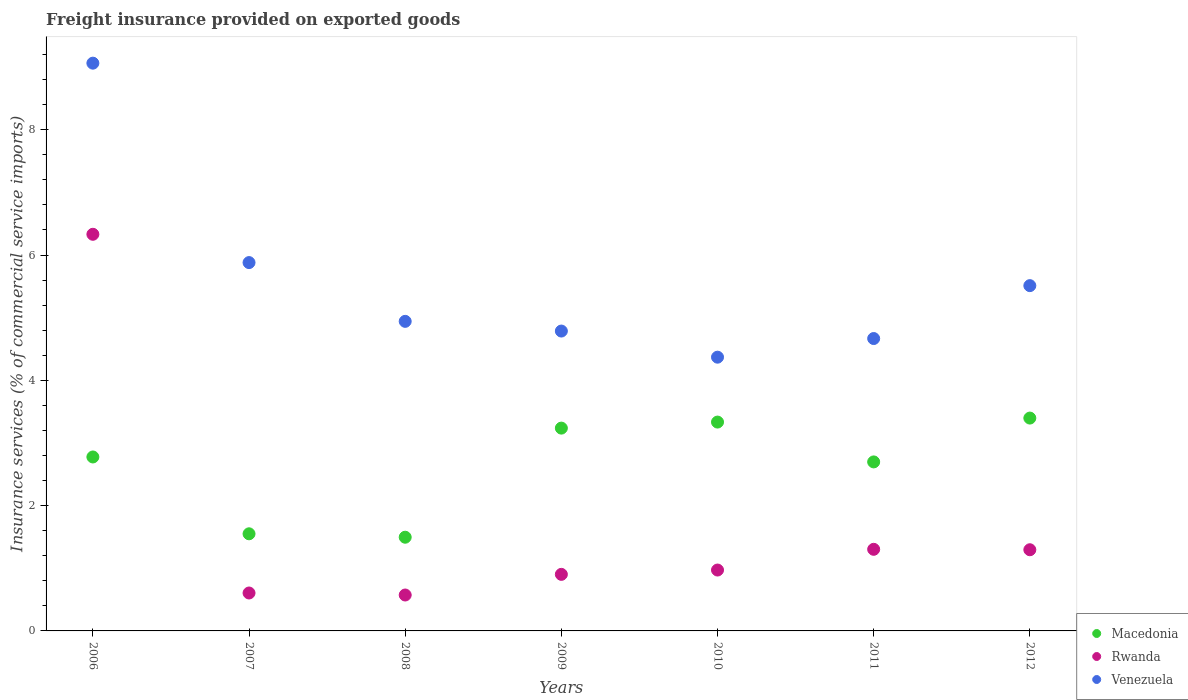How many different coloured dotlines are there?
Your answer should be very brief. 3. What is the freight insurance provided on exported goods in Macedonia in 2008?
Your answer should be very brief. 1.5. Across all years, what is the maximum freight insurance provided on exported goods in Venezuela?
Your response must be concise. 9.06. Across all years, what is the minimum freight insurance provided on exported goods in Macedonia?
Keep it short and to the point. 1.5. What is the total freight insurance provided on exported goods in Rwanda in the graph?
Offer a terse response. 11.98. What is the difference between the freight insurance provided on exported goods in Rwanda in 2008 and that in 2012?
Ensure brevity in your answer.  -0.72. What is the difference between the freight insurance provided on exported goods in Macedonia in 2006 and the freight insurance provided on exported goods in Rwanda in 2012?
Make the answer very short. 1.48. What is the average freight insurance provided on exported goods in Rwanda per year?
Keep it short and to the point. 1.71. In the year 2008, what is the difference between the freight insurance provided on exported goods in Rwanda and freight insurance provided on exported goods in Venezuela?
Your response must be concise. -4.37. In how many years, is the freight insurance provided on exported goods in Rwanda greater than 4 %?
Offer a very short reply. 1. What is the ratio of the freight insurance provided on exported goods in Rwanda in 2007 to that in 2012?
Provide a succinct answer. 0.47. Is the difference between the freight insurance provided on exported goods in Rwanda in 2011 and 2012 greater than the difference between the freight insurance provided on exported goods in Venezuela in 2011 and 2012?
Offer a terse response. Yes. What is the difference between the highest and the second highest freight insurance provided on exported goods in Rwanda?
Ensure brevity in your answer.  5.03. What is the difference between the highest and the lowest freight insurance provided on exported goods in Macedonia?
Give a very brief answer. 1.9. In how many years, is the freight insurance provided on exported goods in Venezuela greater than the average freight insurance provided on exported goods in Venezuela taken over all years?
Your answer should be compact. 2. Is the freight insurance provided on exported goods in Venezuela strictly less than the freight insurance provided on exported goods in Macedonia over the years?
Offer a terse response. No. What is the difference between two consecutive major ticks on the Y-axis?
Give a very brief answer. 2. Are the values on the major ticks of Y-axis written in scientific E-notation?
Provide a short and direct response. No. Does the graph contain any zero values?
Offer a terse response. No. Does the graph contain grids?
Ensure brevity in your answer.  No. How many legend labels are there?
Your response must be concise. 3. How are the legend labels stacked?
Give a very brief answer. Vertical. What is the title of the graph?
Provide a succinct answer. Freight insurance provided on exported goods. Does "Mongolia" appear as one of the legend labels in the graph?
Provide a succinct answer. No. What is the label or title of the Y-axis?
Offer a very short reply. Insurance services (% of commercial service imports). What is the Insurance services (% of commercial service imports) of Macedonia in 2006?
Your response must be concise. 2.78. What is the Insurance services (% of commercial service imports) of Rwanda in 2006?
Ensure brevity in your answer.  6.33. What is the Insurance services (% of commercial service imports) in Venezuela in 2006?
Keep it short and to the point. 9.06. What is the Insurance services (% of commercial service imports) in Macedonia in 2007?
Provide a short and direct response. 1.55. What is the Insurance services (% of commercial service imports) in Rwanda in 2007?
Keep it short and to the point. 0.61. What is the Insurance services (% of commercial service imports) of Venezuela in 2007?
Ensure brevity in your answer.  5.88. What is the Insurance services (% of commercial service imports) in Macedonia in 2008?
Make the answer very short. 1.5. What is the Insurance services (% of commercial service imports) in Rwanda in 2008?
Your response must be concise. 0.57. What is the Insurance services (% of commercial service imports) in Venezuela in 2008?
Provide a short and direct response. 4.94. What is the Insurance services (% of commercial service imports) of Macedonia in 2009?
Give a very brief answer. 3.24. What is the Insurance services (% of commercial service imports) in Rwanda in 2009?
Your response must be concise. 0.9. What is the Insurance services (% of commercial service imports) of Venezuela in 2009?
Provide a short and direct response. 4.79. What is the Insurance services (% of commercial service imports) in Macedonia in 2010?
Provide a short and direct response. 3.33. What is the Insurance services (% of commercial service imports) of Rwanda in 2010?
Offer a very short reply. 0.97. What is the Insurance services (% of commercial service imports) in Venezuela in 2010?
Your answer should be very brief. 4.37. What is the Insurance services (% of commercial service imports) of Macedonia in 2011?
Give a very brief answer. 2.7. What is the Insurance services (% of commercial service imports) of Rwanda in 2011?
Your answer should be compact. 1.3. What is the Insurance services (% of commercial service imports) in Venezuela in 2011?
Provide a succinct answer. 4.67. What is the Insurance services (% of commercial service imports) in Macedonia in 2012?
Offer a terse response. 3.4. What is the Insurance services (% of commercial service imports) in Rwanda in 2012?
Your answer should be very brief. 1.3. What is the Insurance services (% of commercial service imports) in Venezuela in 2012?
Keep it short and to the point. 5.51. Across all years, what is the maximum Insurance services (% of commercial service imports) in Macedonia?
Make the answer very short. 3.4. Across all years, what is the maximum Insurance services (% of commercial service imports) of Rwanda?
Provide a succinct answer. 6.33. Across all years, what is the maximum Insurance services (% of commercial service imports) in Venezuela?
Your response must be concise. 9.06. Across all years, what is the minimum Insurance services (% of commercial service imports) in Macedonia?
Offer a terse response. 1.5. Across all years, what is the minimum Insurance services (% of commercial service imports) of Rwanda?
Offer a very short reply. 0.57. Across all years, what is the minimum Insurance services (% of commercial service imports) of Venezuela?
Your answer should be compact. 4.37. What is the total Insurance services (% of commercial service imports) in Macedonia in the graph?
Your answer should be compact. 18.49. What is the total Insurance services (% of commercial service imports) of Rwanda in the graph?
Offer a very short reply. 11.98. What is the total Insurance services (% of commercial service imports) of Venezuela in the graph?
Your answer should be very brief. 39.22. What is the difference between the Insurance services (% of commercial service imports) in Macedonia in 2006 and that in 2007?
Your answer should be compact. 1.23. What is the difference between the Insurance services (% of commercial service imports) of Rwanda in 2006 and that in 2007?
Your answer should be very brief. 5.73. What is the difference between the Insurance services (% of commercial service imports) of Venezuela in 2006 and that in 2007?
Your answer should be compact. 3.18. What is the difference between the Insurance services (% of commercial service imports) in Macedonia in 2006 and that in 2008?
Your response must be concise. 1.28. What is the difference between the Insurance services (% of commercial service imports) of Rwanda in 2006 and that in 2008?
Your response must be concise. 5.76. What is the difference between the Insurance services (% of commercial service imports) in Venezuela in 2006 and that in 2008?
Your answer should be compact. 4.12. What is the difference between the Insurance services (% of commercial service imports) of Macedonia in 2006 and that in 2009?
Your answer should be compact. -0.46. What is the difference between the Insurance services (% of commercial service imports) in Rwanda in 2006 and that in 2009?
Provide a succinct answer. 5.43. What is the difference between the Insurance services (% of commercial service imports) in Venezuela in 2006 and that in 2009?
Offer a very short reply. 4.28. What is the difference between the Insurance services (% of commercial service imports) in Macedonia in 2006 and that in 2010?
Provide a short and direct response. -0.56. What is the difference between the Insurance services (% of commercial service imports) in Rwanda in 2006 and that in 2010?
Keep it short and to the point. 5.36. What is the difference between the Insurance services (% of commercial service imports) of Venezuela in 2006 and that in 2010?
Provide a succinct answer. 4.69. What is the difference between the Insurance services (% of commercial service imports) in Macedonia in 2006 and that in 2011?
Your answer should be very brief. 0.08. What is the difference between the Insurance services (% of commercial service imports) in Rwanda in 2006 and that in 2011?
Offer a terse response. 5.03. What is the difference between the Insurance services (% of commercial service imports) of Venezuela in 2006 and that in 2011?
Provide a succinct answer. 4.4. What is the difference between the Insurance services (% of commercial service imports) of Macedonia in 2006 and that in 2012?
Offer a very short reply. -0.62. What is the difference between the Insurance services (% of commercial service imports) of Rwanda in 2006 and that in 2012?
Ensure brevity in your answer.  5.04. What is the difference between the Insurance services (% of commercial service imports) of Venezuela in 2006 and that in 2012?
Offer a terse response. 3.55. What is the difference between the Insurance services (% of commercial service imports) in Macedonia in 2007 and that in 2008?
Your answer should be compact. 0.05. What is the difference between the Insurance services (% of commercial service imports) of Rwanda in 2007 and that in 2008?
Provide a short and direct response. 0.03. What is the difference between the Insurance services (% of commercial service imports) in Venezuela in 2007 and that in 2008?
Offer a terse response. 0.94. What is the difference between the Insurance services (% of commercial service imports) of Macedonia in 2007 and that in 2009?
Provide a succinct answer. -1.69. What is the difference between the Insurance services (% of commercial service imports) in Rwanda in 2007 and that in 2009?
Your response must be concise. -0.3. What is the difference between the Insurance services (% of commercial service imports) in Venezuela in 2007 and that in 2009?
Provide a succinct answer. 1.09. What is the difference between the Insurance services (% of commercial service imports) in Macedonia in 2007 and that in 2010?
Offer a very short reply. -1.78. What is the difference between the Insurance services (% of commercial service imports) in Rwanda in 2007 and that in 2010?
Keep it short and to the point. -0.37. What is the difference between the Insurance services (% of commercial service imports) in Venezuela in 2007 and that in 2010?
Your response must be concise. 1.51. What is the difference between the Insurance services (% of commercial service imports) in Macedonia in 2007 and that in 2011?
Provide a short and direct response. -1.15. What is the difference between the Insurance services (% of commercial service imports) in Rwanda in 2007 and that in 2011?
Your answer should be compact. -0.7. What is the difference between the Insurance services (% of commercial service imports) in Venezuela in 2007 and that in 2011?
Make the answer very short. 1.21. What is the difference between the Insurance services (% of commercial service imports) in Macedonia in 2007 and that in 2012?
Offer a very short reply. -1.85. What is the difference between the Insurance services (% of commercial service imports) in Rwanda in 2007 and that in 2012?
Offer a terse response. -0.69. What is the difference between the Insurance services (% of commercial service imports) of Venezuela in 2007 and that in 2012?
Give a very brief answer. 0.37. What is the difference between the Insurance services (% of commercial service imports) in Macedonia in 2008 and that in 2009?
Make the answer very short. -1.74. What is the difference between the Insurance services (% of commercial service imports) of Rwanda in 2008 and that in 2009?
Provide a succinct answer. -0.33. What is the difference between the Insurance services (% of commercial service imports) of Venezuela in 2008 and that in 2009?
Your answer should be very brief. 0.15. What is the difference between the Insurance services (% of commercial service imports) in Macedonia in 2008 and that in 2010?
Offer a very short reply. -1.84. What is the difference between the Insurance services (% of commercial service imports) in Rwanda in 2008 and that in 2010?
Provide a short and direct response. -0.4. What is the difference between the Insurance services (% of commercial service imports) in Venezuela in 2008 and that in 2010?
Your answer should be very brief. 0.57. What is the difference between the Insurance services (% of commercial service imports) of Macedonia in 2008 and that in 2011?
Ensure brevity in your answer.  -1.2. What is the difference between the Insurance services (% of commercial service imports) of Rwanda in 2008 and that in 2011?
Ensure brevity in your answer.  -0.73. What is the difference between the Insurance services (% of commercial service imports) in Venezuela in 2008 and that in 2011?
Offer a terse response. 0.27. What is the difference between the Insurance services (% of commercial service imports) in Macedonia in 2008 and that in 2012?
Keep it short and to the point. -1.9. What is the difference between the Insurance services (% of commercial service imports) of Rwanda in 2008 and that in 2012?
Give a very brief answer. -0.72. What is the difference between the Insurance services (% of commercial service imports) in Venezuela in 2008 and that in 2012?
Ensure brevity in your answer.  -0.57. What is the difference between the Insurance services (% of commercial service imports) of Macedonia in 2009 and that in 2010?
Ensure brevity in your answer.  -0.1. What is the difference between the Insurance services (% of commercial service imports) in Rwanda in 2009 and that in 2010?
Keep it short and to the point. -0.07. What is the difference between the Insurance services (% of commercial service imports) of Venezuela in 2009 and that in 2010?
Your response must be concise. 0.42. What is the difference between the Insurance services (% of commercial service imports) in Macedonia in 2009 and that in 2011?
Make the answer very short. 0.54. What is the difference between the Insurance services (% of commercial service imports) in Rwanda in 2009 and that in 2011?
Your response must be concise. -0.4. What is the difference between the Insurance services (% of commercial service imports) of Venezuela in 2009 and that in 2011?
Provide a short and direct response. 0.12. What is the difference between the Insurance services (% of commercial service imports) in Macedonia in 2009 and that in 2012?
Your answer should be very brief. -0.16. What is the difference between the Insurance services (% of commercial service imports) in Rwanda in 2009 and that in 2012?
Give a very brief answer. -0.39. What is the difference between the Insurance services (% of commercial service imports) of Venezuela in 2009 and that in 2012?
Offer a terse response. -0.72. What is the difference between the Insurance services (% of commercial service imports) of Macedonia in 2010 and that in 2011?
Ensure brevity in your answer.  0.64. What is the difference between the Insurance services (% of commercial service imports) in Rwanda in 2010 and that in 2011?
Your answer should be very brief. -0.33. What is the difference between the Insurance services (% of commercial service imports) in Venezuela in 2010 and that in 2011?
Your answer should be compact. -0.3. What is the difference between the Insurance services (% of commercial service imports) in Macedonia in 2010 and that in 2012?
Your response must be concise. -0.06. What is the difference between the Insurance services (% of commercial service imports) of Rwanda in 2010 and that in 2012?
Your answer should be compact. -0.32. What is the difference between the Insurance services (% of commercial service imports) of Venezuela in 2010 and that in 2012?
Ensure brevity in your answer.  -1.14. What is the difference between the Insurance services (% of commercial service imports) of Macedonia in 2011 and that in 2012?
Give a very brief answer. -0.7. What is the difference between the Insurance services (% of commercial service imports) in Rwanda in 2011 and that in 2012?
Provide a succinct answer. 0.01. What is the difference between the Insurance services (% of commercial service imports) of Venezuela in 2011 and that in 2012?
Keep it short and to the point. -0.84. What is the difference between the Insurance services (% of commercial service imports) of Macedonia in 2006 and the Insurance services (% of commercial service imports) of Rwanda in 2007?
Your answer should be compact. 2.17. What is the difference between the Insurance services (% of commercial service imports) of Macedonia in 2006 and the Insurance services (% of commercial service imports) of Venezuela in 2007?
Keep it short and to the point. -3.1. What is the difference between the Insurance services (% of commercial service imports) in Rwanda in 2006 and the Insurance services (% of commercial service imports) in Venezuela in 2007?
Offer a very short reply. 0.45. What is the difference between the Insurance services (% of commercial service imports) of Macedonia in 2006 and the Insurance services (% of commercial service imports) of Rwanda in 2008?
Your answer should be compact. 2.2. What is the difference between the Insurance services (% of commercial service imports) of Macedonia in 2006 and the Insurance services (% of commercial service imports) of Venezuela in 2008?
Offer a terse response. -2.16. What is the difference between the Insurance services (% of commercial service imports) of Rwanda in 2006 and the Insurance services (% of commercial service imports) of Venezuela in 2008?
Give a very brief answer. 1.39. What is the difference between the Insurance services (% of commercial service imports) in Macedonia in 2006 and the Insurance services (% of commercial service imports) in Rwanda in 2009?
Provide a succinct answer. 1.87. What is the difference between the Insurance services (% of commercial service imports) in Macedonia in 2006 and the Insurance services (% of commercial service imports) in Venezuela in 2009?
Your answer should be very brief. -2.01. What is the difference between the Insurance services (% of commercial service imports) of Rwanda in 2006 and the Insurance services (% of commercial service imports) of Venezuela in 2009?
Provide a short and direct response. 1.54. What is the difference between the Insurance services (% of commercial service imports) of Macedonia in 2006 and the Insurance services (% of commercial service imports) of Rwanda in 2010?
Your response must be concise. 1.8. What is the difference between the Insurance services (% of commercial service imports) of Macedonia in 2006 and the Insurance services (% of commercial service imports) of Venezuela in 2010?
Keep it short and to the point. -1.59. What is the difference between the Insurance services (% of commercial service imports) in Rwanda in 2006 and the Insurance services (% of commercial service imports) in Venezuela in 2010?
Offer a very short reply. 1.96. What is the difference between the Insurance services (% of commercial service imports) in Macedonia in 2006 and the Insurance services (% of commercial service imports) in Rwanda in 2011?
Give a very brief answer. 1.47. What is the difference between the Insurance services (% of commercial service imports) in Macedonia in 2006 and the Insurance services (% of commercial service imports) in Venezuela in 2011?
Offer a terse response. -1.89. What is the difference between the Insurance services (% of commercial service imports) in Rwanda in 2006 and the Insurance services (% of commercial service imports) in Venezuela in 2011?
Keep it short and to the point. 1.66. What is the difference between the Insurance services (% of commercial service imports) in Macedonia in 2006 and the Insurance services (% of commercial service imports) in Rwanda in 2012?
Offer a terse response. 1.48. What is the difference between the Insurance services (% of commercial service imports) in Macedonia in 2006 and the Insurance services (% of commercial service imports) in Venezuela in 2012?
Ensure brevity in your answer.  -2.73. What is the difference between the Insurance services (% of commercial service imports) of Rwanda in 2006 and the Insurance services (% of commercial service imports) of Venezuela in 2012?
Ensure brevity in your answer.  0.82. What is the difference between the Insurance services (% of commercial service imports) in Macedonia in 2007 and the Insurance services (% of commercial service imports) in Rwanda in 2008?
Your answer should be very brief. 0.98. What is the difference between the Insurance services (% of commercial service imports) of Macedonia in 2007 and the Insurance services (% of commercial service imports) of Venezuela in 2008?
Ensure brevity in your answer.  -3.39. What is the difference between the Insurance services (% of commercial service imports) of Rwanda in 2007 and the Insurance services (% of commercial service imports) of Venezuela in 2008?
Make the answer very short. -4.34. What is the difference between the Insurance services (% of commercial service imports) in Macedonia in 2007 and the Insurance services (% of commercial service imports) in Rwanda in 2009?
Provide a succinct answer. 0.65. What is the difference between the Insurance services (% of commercial service imports) in Macedonia in 2007 and the Insurance services (% of commercial service imports) in Venezuela in 2009?
Offer a terse response. -3.24. What is the difference between the Insurance services (% of commercial service imports) of Rwanda in 2007 and the Insurance services (% of commercial service imports) of Venezuela in 2009?
Provide a succinct answer. -4.18. What is the difference between the Insurance services (% of commercial service imports) in Macedonia in 2007 and the Insurance services (% of commercial service imports) in Rwanda in 2010?
Ensure brevity in your answer.  0.58. What is the difference between the Insurance services (% of commercial service imports) of Macedonia in 2007 and the Insurance services (% of commercial service imports) of Venezuela in 2010?
Your answer should be very brief. -2.82. What is the difference between the Insurance services (% of commercial service imports) of Rwanda in 2007 and the Insurance services (% of commercial service imports) of Venezuela in 2010?
Offer a terse response. -3.76. What is the difference between the Insurance services (% of commercial service imports) of Macedonia in 2007 and the Insurance services (% of commercial service imports) of Rwanda in 2011?
Keep it short and to the point. 0.25. What is the difference between the Insurance services (% of commercial service imports) of Macedonia in 2007 and the Insurance services (% of commercial service imports) of Venezuela in 2011?
Your answer should be compact. -3.12. What is the difference between the Insurance services (% of commercial service imports) of Rwanda in 2007 and the Insurance services (% of commercial service imports) of Venezuela in 2011?
Provide a succinct answer. -4.06. What is the difference between the Insurance services (% of commercial service imports) in Macedonia in 2007 and the Insurance services (% of commercial service imports) in Rwanda in 2012?
Provide a succinct answer. 0.25. What is the difference between the Insurance services (% of commercial service imports) of Macedonia in 2007 and the Insurance services (% of commercial service imports) of Venezuela in 2012?
Offer a very short reply. -3.96. What is the difference between the Insurance services (% of commercial service imports) in Rwanda in 2007 and the Insurance services (% of commercial service imports) in Venezuela in 2012?
Ensure brevity in your answer.  -4.91. What is the difference between the Insurance services (% of commercial service imports) in Macedonia in 2008 and the Insurance services (% of commercial service imports) in Rwanda in 2009?
Offer a terse response. 0.59. What is the difference between the Insurance services (% of commercial service imports) of Macedonia in 2008 and the Insurance services (% of commercial service imports) of Venezuela in 2009?
Ensure brevity in your answer.  -3.29. What is the difference between the Insurance services (% of commercial service imports) of Rwanda in 2008 and the Insurance services (% of commercial service imports) of Venezuela in 2009?
Your response must be concise. -4.21. What is the difference between the Insurance services (% of commercial service imports) of Macedonia in 2008 and the Insurance services (% of commercial service imports) of Rwanda in 2010?
Offer a very short reply. 0.52. What is the difference between the Insurance services (% of commercial service imports) in Macedonia in 2008 and the Insurance services (% of commercial service imports) in Venezuela in 2010?
Your response must be concise. -2.87. What is the difference between the Insurance services (% of commercial service imports) in Rwanda in 2008 and the Insurance services (% of commercial service imports) in Venezuela in 2010?
Your response must be concise. -3.8. What is the difference between the Insurance services (% of commercial service imports) in Macedonia in 2008 and the Insurance services (% of commercial service imports) in Rwanda in 2011?
Give a very brief answer. 0.19. What is the difference between the Insurance services (% of commercial service imports) in Macedonia in 2008 and the Insurance services (% of commercial service imports) in Venezuela in 2011?
Your response must be concise. -3.17. What is the difference between the Insurance services (% of commercial service imports) of Rwanda in 2008 and the Insurance services (% of commercial service imports) of Venezuela in 2011?
Provide a short and direct response. -4.09. What is the difference between the Insurance services (% of commercial service imports) of Macedonia in 2008 and the Insurance services (% of commercial service imports) of Rwanda in 2012?
Ensure brevity in your answer.  0.2. What is the difference between the Insurance services (% of commercial service imports) of Macedonia in 2008 and the Insurance services (% of commercial service imports) of Venezuela in 2012?
Ensure brevity in your answer.  -4.02. What is the difference between the Insurance services (% of commercial service imports) in Rwanda in 2008 and the Insurance services (% of commercial service imports) in Venezuela in 2012?
Make the answer very short. -4.94. What is the difference between the Insurance services (% of commercial service imports) of Macedonia in 2009 and the Insurance services (% of commercial service imports) of Rwanda in 2010?
Make the answer very short. 2.27. What is the difference between the Insurance services (% of commercial service imports) of Macedonia in 2009 and the Insurance services (% of commercial service imports) of Venezuela in 2010?
Offer a very short reply. -1.13. What is the difference between the Insurance services (% of commercial service imports) in Rwanda in 2009 and the Insurance services (% of commercial service imports) in Venezuela in 2010?
Provide a short and direct response. -3.47. What is the difference between the Insurance services (% of commercial service imports) of Macedonia in 2009 and the Insurance services (% of commercial service imports) of Rwanda in 2011?
Make the answer very short. 1.93. What is the difference between the Insurance services (% of commercial service imports) in Macedonia in 2009 and the Insurance services (% of commercial service imports) in Venezuela in 2011?
Provide a short and direct response. -1.43. What is the difference between the Insurance services (% of commercial service imports) in Rwanda in 2009 and the Insurance services (% of commercial service imports) in Venezuela in 2011?
Your answer should be compact. -3.76. What is the difference between the Insurance services (% of commercial service imports) in Macedonia in 2009 and the Insurance services (% of commercial service imports) in Rwanda in 2012?
Your response must be concise. 1.94. What is the difference between the Insurance services (% of commercial service imports) in Macedonia in 2009 and the Insurance services (% of commercial service imports) in Venezuela in 2012?
Your answer should be very brief. -2.27. What is the difference between the Insurance services (% of commercial service imports) in Rwanda in 2009 and the Insurance services (% of commercial service imports) in Venezuela in 2012?
Give a very brief answer. -4.61. What is the difference between the Insurance services (% of commercial service imports) in Macedonia in 2010 and the Insurance services (% of commercial service imports) in Rwanda in 2011?
Your answer should be very brief. 2.03. What is the difference between the Insurance services (% of commercial service imports) of Macedonia in 2010 and the Insurance services (% of commercial service imports) of Venezuela in 2011?
Your response must be concise. -1.33. What is the difference between the Insurance services (% of commercial service imports) of Rwanda in 2010 and the Insurance services (% of commercial service imports) of Venezuela in 2011?
Keep it short and to the point. -3.7. What is the difference between the Insurance services (% of commercial service imports) of Macedonia in 2010 and the Insurance services (% of commercial service imports) of Rwanda in 2012?
Provide a short and direct response. 2.04. What is the difference between the Insurance services (% of commercial service imports) of Macedonia in 2010 and the Insurance services (% of commercial service imports) of Venezuela in 2012?
Your answer should be compact. -2.18. What is the difference between the Insurance services (% of commercial service imports) in Rwanda in 2010 and the Insurance services (% of commercial service imports) in Venezuela in 2012?
Offer a terse response. -4.54. What is the difference between the Insurance services (% of commercial service imports) in Macedonia in 2011 and the Insurance services (% of commercial service imports) in Rwanda in 2012?
Provide a short and direct response. 1.4. What is the difference between the Insurance services (% of commercial service imports) in Macedonia in 2011 and the Insurance services (% of commercial service imports) in Venezuela in 2012?
Offer a terse response. -2.81. What is the difference between the Insurance services (% of commercial service imports) in Rwanda in 2011 and the Insurance services (% of commercial service imports) in Venezuela in 2012?
Make the answer very short. -4.21. What is the average Insurance services (% of commercial service imports) in Macedonia per year?
Give a very brief answer. 2.64. What is the average Insurance services (% of commercial service imports) of Rwanda per year?
Offer a terse response. 1.71. What is the average Insurance services (% of commercial service imports) in Venezuela per year?
Your answer should be very brief. 5.6. In the year 2006, what is the difference between the Insurance services (% of commercial service imports) in Macedonia and Insurance services (% of commercial service imports) in Rwanda?
Offer a terse response. -3.55. In the year 2006, what is the difference between the Insurance services (% of commercial service imports) of Macedonia and Insurance services (% of commercial service imports) of Venezuela?
Provide a short and direct response. -6.29. In the year 2006, what is the difference between the Insurance services (% of commercial service imports) in Rwanda and Insurance services (% of commercial service imports) in Venezuela?
Offer a terse response. -2.73. In the year 2007, what is the difference between the Insurance services (% of commercial service imports) in Macedonia and Insurance services (% of commercial service imports) in Rwanda?
Provide a succinct answer. 0.94. In the year 2007, what is the difference between the Insurance services (% of commercial service imports) of Macedonia and Insurance services (% of commercial service imports) of Venezuela?
Make the answer very short. -4.33. In the year 2007, what is the difference between the Insurance services (% of commercial service imports) in Rwanda and Insurance services (% of commercial service imports) in Venezuela?
Your response must be concise. -5.27. In the year 2008, what is the difference between the Insurance services (% of commercial service imports) in Macedonia and Insurance services (% of commercial service imports) in Rwanda?
Give a very brief answer. 0.92. In the year 2008, what is the difference between the Insurance services (% of commercial service imports) in Macedonia and Insurance services (% of commercial service imports) in Venezuela?
Keep it short and to the point. -3.45. In the year 2008, what is the difference between the Insurance services (% of commercial service imports) of Rwanda and Insurance services (% of commercial service imports) of Venezuela?
Your answer should be compact. -4.37. In the year 2009, what is the difference between the Insurance services (% of commercial service imports) in Macedonia and Insurance services (% of commercial service imports) in Rwanda?
Make the answer very short. 2.33. In the year 2009, what is the difference between the Insurance services (% of commercial service imports) in Macedonia and Insurance services (% of commercial service imports) in Venezuela?
Your response must be concise. -1.55. In the year 2009, what is the difference between the Insurance services (% of commercial service imports) in Rwanda and Insurance services (% of commercial service imports) in Venezuela?
Your answer should be very brief. -3.88. In the year 2010, what is the difference between the Insurance services (% of commercial service imports) of Macedonia and Insurance services (% of commercial service imports) of Rwanda?
Ensure brevity in your answer.  2.36. In the year 2010, what is the difference between the Insurance services (% of commercial service imports) of Macedonia and Insurance services (% of commercial service imports) of Venezuela?
Offer a very short reply. -1.04. In the year 2010, what is the difference between the Insurance services (% of commercial service imports) in Rwanda and Insurance services (% of commercial service imports) in Venezuela?
Provide a short and direct response. -3.4. In the year 2011, what is the difference between the Insurance services (% of commercial service imports) in Macedonia and Insurance services (% of commercial service imports) in Rwanda?
Make the answer very short. 1.4. In the year 2011, what is the difference between the Insurance services (% of commercial service imports) in Macedonia and Insurance services (% of commercial service imports) in Venezuela?
Your response must be concise. -1.97. In the year 2011, what is the difference between the Insurance services (% of commercial service imports) in Rwanda and Insurance services (% of commercial service imports) in Venezuela?
Your answer should be very brief. -3.36. In the year 2012, what is the difference between the Insurance services (% of commercial service imports) in Macedonia and Insurance services (% of commercial service imports) in Rwanda?
Your answer should be compact. 2.1. In the year 2012, what is the difference between the Insurance services (% of commercial service imports) of Macedonia and Insurance services (% of commercial service imports) of Venezuela?
Your response must be concise. -2.11. In the year 2012, what is the difference between the Insurance services (% of commercial service imports) of Rwanda and Insurance services (% of commercial service imports) of Venezuela?
Provide a short and direct response. -4.22. What is the ratio of the Insurance services (% of commercial service imports) in Macedonia in 2006 to that in 2007?
Offer a very short reply. 1.79. What is the ratio of the Insurance services (% of commercial service imports) of Rwanda in 2006 to that in 2007?
Offer a very short reply. 10.46. What is the ratio of the Insurance services (% of commercial service imports) of Venezuela in 2006 to that in 2007?
Make the answer very short. 1.54. What is the ratio of the Insurance services (% of commercial service imports) of Macedonia in 2006 to that in 2008?
Your response must be concise. 1.86. What is the ratio of the Insurance services (% of commercial service imports) in Rwanda in 2006 to that in 2008?
Offer a very short reply. 11.04. What is the ratio of the Insurance services (% of commercial service imports) of Venezuela in 2006 to that in 2008?
Your answer should be very brief. 1.83. What is the ratio of the Insurance services (% of commercial service imports) in Macedonia in 2006 to that in 2009?
Offer a very short reply. 0.86. What is the ratio of the Insurance services (% of commercial service imports) in Rwanda in 2006 to that in 2009?
Offer a terse response. 7.01. What is the ratio of the Insurance services (% of commercial service imports) in Venezuela in 2006 to that in 2009?
Provide a short and direct response. 1.89. What is the ratio of the Insurance services (% of commercial service imports) of Macedonia in 2006 to that in 2010?
Make the answer very short. 0.83. What is the ratio of the Insurance services (% of commercial service imports) in Rwanda in 2006 to that in 2010?
Your response must be concise. 6.51. What is the ratio of the Insurance services (% of commercial service imports) in Venezuela in 2006 to that in 2010?
Give a very brief answer. 2.07. What is the ratio of the Insurance services (% of commercial service imports) in Macedonia in 2006 to that in 2011?
Your answer should be very brief. 1.03. What is the ratio of the Insurance services (% of commercial service imports) in Rwanda in 2006 to that in 2011?
Give a very brief answer. 4.86. What is the ratio of the Insurance services (% of commercial service imports) in Venezuela in 2006 to that in 2011?
Ensure brevity in your answer.  1.94. What is the ratio of the Insurance services (% of commercial service imports) in Macedonia in 2006 to that in 2012?
Your answer should be very brief. 0.82. What is the ratio of the Insurance services (% of commercial service imports) of Rwanda in 2006 to that in 2012?
Keep it short and to the point. 4.89. What is the ratio of the Insurance services (% of commercial service imports) of Venezuela in 2006 to that in 2012?
Make the answer very short. 1.64. What is the ratio of the Insurance services (% of commercial service imports) in Macedonia in 2007 to that in 2008?
Give a very brief answer. 1.04. What is the ratio of the Insurance services (% of commercial service imports) in Rwanda in 2007 to that in 2008?
Your answer should be compact. 1.06. What is the ratio of the Insurance services (% of commercial service imports) of Venezuela in 2007 to that in 2008?
Provide a short and direct response. 1.19. What is the ratio of the Insurance services (% of commercial service imports) of Macedonia in 2007 to that in 2009?
Make the answer very short. 0.48. What is the ratio of the Insurance services (% of commercial service imports) of Rwanda in 2007 to that in 2009?
Ensure brevity in your answer.  0.67. What is the ratio of the Insurance services (% of commercial service imports) of Venezuela in 2007 to that in 2009?
Offer a very short reply. 1.23. What is the ratio of the Insurance services (% of commercial service imports) in Macedonia in 2007 to that in 2010?
Offer a very short reply. 0.47. What is the ratio of the Insurance services (% of commercial service imports) in Rwanda in 2007 to that in 2010?
Provide a succinct answer. 0.62. What is the ratio of the Insurance services (% of commercial service imports) in Venezuela in 2007 to that in 2010?
Offer a terse response. 1.35. What is the ratio of the Insurance services (% of commercial service imports) in Macedonia in 2007 to that in 2011?
Keep it short and to the point. 0.57. What is the ratio of the Insurance services (% of commercial service imports) of Rwanda in 2007 to that in 2011?
Make the answer very short. 0.46. What is the ratio of the Insurance services (% of commercial service imports) in Venezuela in 2007 to that in 2011?
Your answer should be compact. 1.26. What is the ratio of the Insurance services (% of commercial service imports) in Macedonia in 2007 to that in 2012?
Give a very brief answer. 0.46. What is the ratio of the Insurance services (% of commercial service imports) in Rwanda in 2007 to that in 2012?
Provide a short and direct response. 0.47. What is the ratio of the Insurance services (% of commercial service imports) of Venezuela in 2007 to that in 2012?
Provide a short and direct response. 1.07. What is the ratio of the Insurance services (% of commercial service imports) of Macedonia in 2008 to that in 2009?
Provide a succinct answer. 0.46. What is the ratio of the Insurance services (% of commercial service imports) of Rwanda in 2008 to that in 2009?
Make the answer very short. 0.64. What is the ratio of the Insurance services (% of commercial service imports) in Venezuela in 2008 to that in 2009?
Your response must be concise. 1.03. What is the ratio of the Insurance services (% of commercial service imports) of Macedonia in 2008 to that in 2010?
Provide a succinct answer. 0.45. What is the ratio of the Insurance services (% of commercial service imports) of Rwanda in 2008 to that in 2010?
Give a very brief answer. 0.59. What is the ratio of the Insurance services (% of commercial service imports) of Venezuela in 2008 to that in 2010?
Provide a succinct answer. 1.13. What is the ratio of the Insurance services (% of commercial service imports) in Macedonia in 2008 to that in 2011?
Your answer should be very brief. 0.55. What is the ratio of the Insurance services (% of commercial service imports) of Rwanda in 2008 to that in 2011?
Provide a succinct answer. 0.44. What is the ratio of the Insurance services (% of commercial service imports) in Venezuela in 2008 to that in 2011?
Make the answer very short. 1.06. What is the ratio of the Insurance services (% of commercial service imports) of Macedonia in 2008 to that in 2012?
Your response must be concise. 0.44. What is the ratio of the Insurance services (% of commercial service imports) in Rwanda in 2008 to that in 2012?
Offer a very short reply. 0.44. What is the ratio of the Insurance services (% of commercial service imports) of Venezuela in 2008 to that in 2012?
Give a very brief answer. 0.9. What is the ratio of the Insurance services (% of commercial service imports) of Macedonia in 2009 to that in 2010?
Provide a short and direct response. 0.97. What is the ratio of the Insurance services (% of commercial service imports) in Rwanda in 2009 to that in 2010?
Your response must be concise. 0.93. What is the ratio of the Insurance services (% of commercial service imports) in Venezuela in 2009 to that in 2010?
Provide a short and direct response. 1.1. What is the ratio of the Insurance services (% of commercial service imports) of Macedonia in 2009 to that in 2011?
Give a very brief answer. 1.2. What is the ratio of the Insurance services (% of commercial service imports) of Rwanda in 2009 to that in 2011?
Provide a succinct answer. 0.69. What is the ratio of the Insurance services (% of commercial service imports) in Venezuela in 2009 to that in 2011?
Your response must be concise. 1.03. What is the ratio of the Insurance services (% of commercial service imports) in Macedonia in 2009 to that in 2012?
Your answer should be compact. 0.95. What is the ratio of the Insurance services (% of commercial service imports) of Rwanda in 2009 to that in 2012?
Offer a very short reply. 0.7. What is the ratio of the Insurance services (% of commercial service imports) of Venezuela in 2009 to that in 2012?
Ensure brevity in your answer.  0.87. What is the ratio of the Insurance services (% of commercial service imports) of Macedonia in 2010 to that in 2011?
Give a very brief answer. 1.24. What is the ratio of the Insurance services (% of commercial service imports) in Rwanda in 2010 to that in 2011?
Your answer should be compact. 0.75. What is the ratio of the Insurance services (% of commercial service imports) in Venezuela in 2010 to that in 2011?
Make the answer very short. 0.94. What is the ratio of the Insurance services (% of commercial service imports) of Macedonia in 2010 to that in 2012?
Provide a short and direct response. 0.98. What is the ratio of the Insurance services (% of commercial service imports) in Rwanda in 2010 to that in 2012?
Your response must be concise. 0.75. What is the ratio of the Insurance services (% of commercial service imports) of Venezuela in 2010 to that in 2012?
Your answer should be compact. 0.79. What is the ratio of the Insurance services (% of commercial service imports) in Macedonia in 2011 to that in 2012?
Keep it short and to the point. 0.79. What is the ratio of the Insurance services (% of commercial service imports) in Rwanda in 2011 to that in 2012?
Your answer should be very brief. 1.01. What is the ratio of the Insurance services (% of commercial service imports) of Venezuela in 2011 to that in 2012?
Your response must be concise. 0.85. What is the difference between the highest and the second highest Insurance services (% of commercial service imports) of Macedonia?
Ensure brevity in your answer.  0.06. What is the difference between the highest and the second highest Insurance services (% of commercial service imports) of Rwanda?
Give a very brief answer. 5.03. What is the difference between the highest and the second highest Insurance services (% of commercial service imports) of Venezuela?
Make the answer very short. 3.18. What is the difference between the highest and the lowest Insurance services (% of commercial service imports) of Macedonia?
Your answer should be compact. 1.9. What is the difference between the highest and the lowest Insurance services (% of commercial service imports) in Rwanda?
Offer a terse response. 5.76. What is the difference between the highest and the lowest Insurance services (% of commercial service imports) of Venezuela?
Your answer should be very brief. 4.69. 